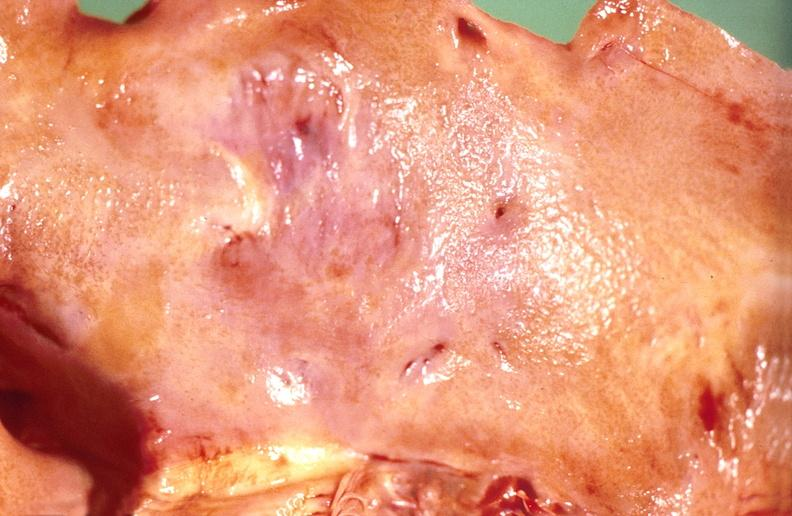does this image show amyloidosis?
Answer the question using a single word or phrase. Yes 